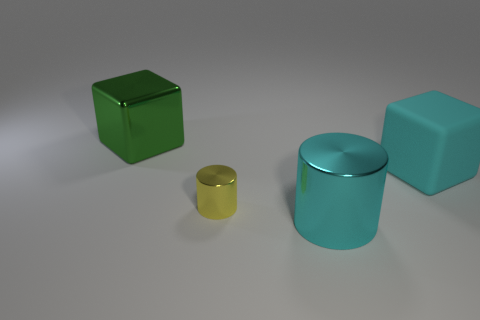Can you tell me what the lighting in this scene suggests about the setting? The image features soft, diffused lighting with subtle shadows, which indicate an indoor setting with a possible overhead light source. The absence of harsh shadows or bright highlights suggests the light is not direct sunlight. 